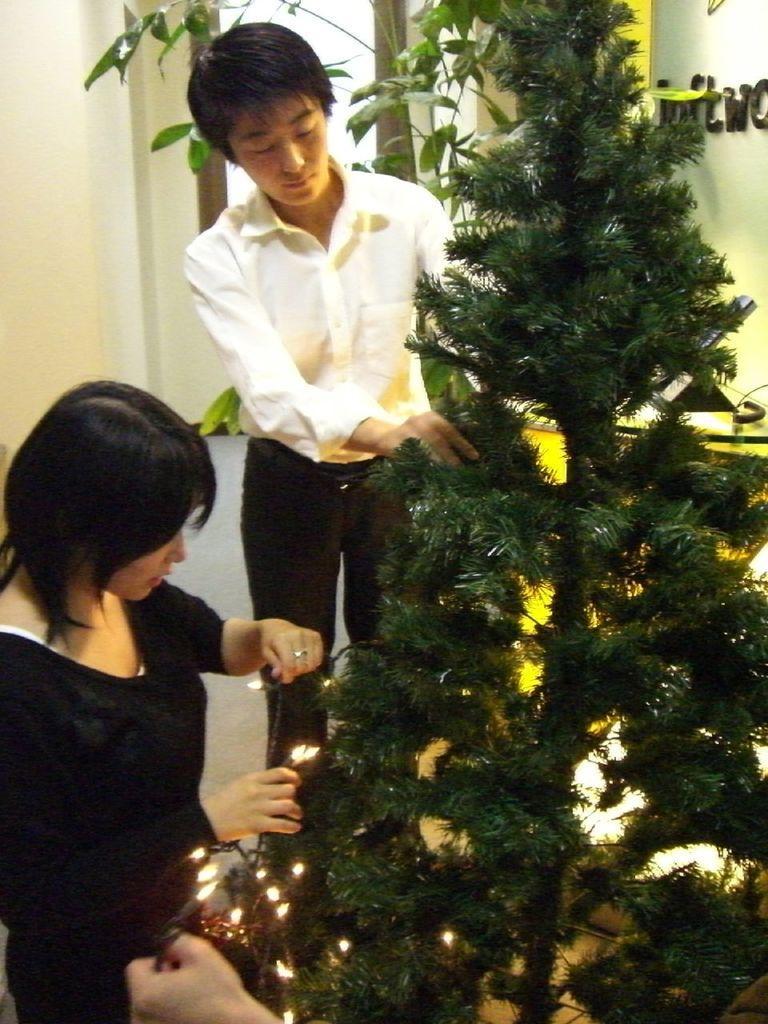How would you summarize this image in a sentence or two? This picture describes about few people, they are decorating the Christmas tree, and she is holding lights in her hands. 